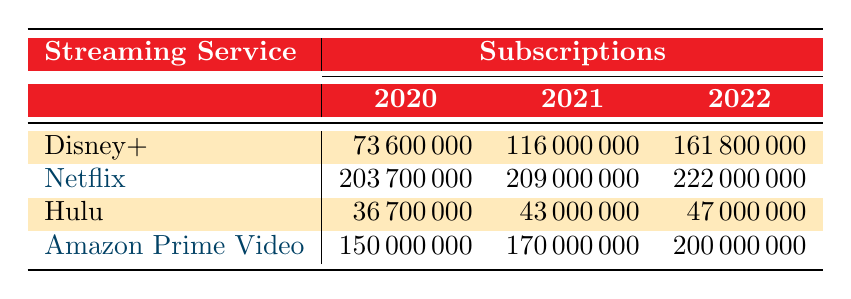What was the number of subscriptions for Disney+ in 2021? Looking at the row for Disney+, the value for the year 2021 is clearly stated as 116000000.
Answer: 116000000 Which streaming service had the highest number of subscriptions in 2022? By comparing the subscriptions for all services in 2022, Netflix has 222000000, which is greater than Disney+ (161800000), Hulu (47000000), and Amazon Prime Video (200000000).
Answer: Netflix What is the total number of subscriptions for Hulu from 2020 to 2022? The subscriptions for Hulu in each year are 36700000 (2020), 43000000 (2021), and 47000000 (2022). Adding these gives 36700000 + 43000000 + 47000000 = 126000000.
Answer: 126000000 Did the subscriptions for Amazon Prime Video increase every year from 2020 to 2022? The subscriptions were 150000000 in 2020, 170000000 in 2021, and 200000000 in 2022, indicating an increase each year.
Answer: Yes What is the difference in subscriptions between Netflix and Disney+ for 2021? The subscriptions for Netflix in 2021 are 209000000 and for Disney+ are 116000000. The difference is 209000000 - 116000000 = 93000000.
Answer: 93000000 What was the average number of subscriptions for all services in 2022? The subscriptions in 2022 are 161800000 (Disney+), 222000000 (Netflix), 47000000 (Hulu), and 200000000 (Amazon Prime Video). The total is 161800000 + 222000000 + 47000000 + 200000000 = 632800000. There are 4 services, so the average is 632800000 / 4 = 158200000.
Answer: 158200000 Was there any decrease in subscriptions for any service from 2020 to 2022? By comparing the subscriptions for each service, each one has shown an increase from 2020 to 2022, thus no service had a decrease in subscriptions during this period.
Answer: No Which service saw the smallest subscription increase from 2021 to 2022? Calculating the increase for each service from 2021 to 2022: Disney+ (161800000 - 116000000 = 45800000), Netflix (222000000 - 209000000 = 13000000), Hulu (47000000 - 43000000 = 4000000), Amazon Prime Video (200000000 - 170000000 = 30000000). The smallest increase is for Hulu at 4000000.
Answer: Hulu 